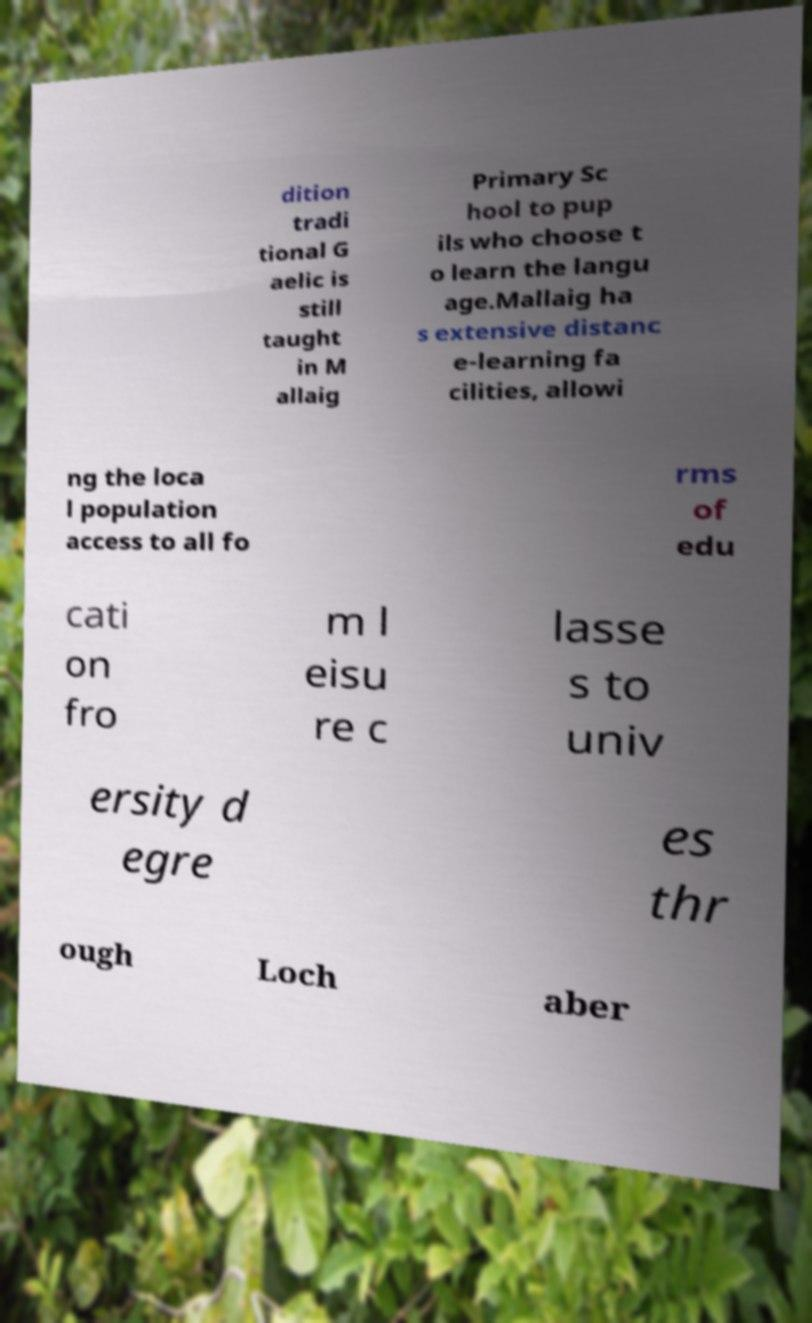I need the written content from this picture converted into text. Can you do that? dition tradi tional G aelic is still taught in M allaig Primary Sc hool to pup ils who choose t o learn the langu age.Mallaig ha s extensive distanc e-learning fa cilities, allowi ng the loca l population access to all fo rms of edu cati on fro m l eisu re c lasse s to univ ersity d egre es thr ough Loch aber 